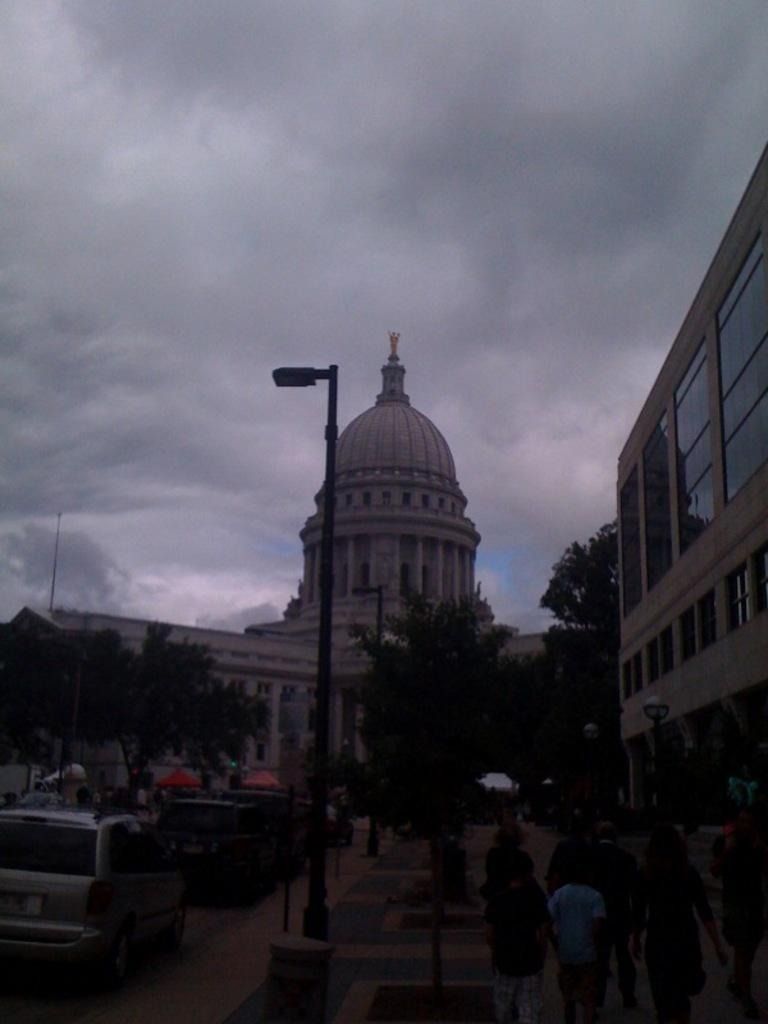What types of objects can be seen in the image? There are vehicles, light poles, trees, and buildings in the image. Can you describe the color scheme of the buildings? The buildings are in cream and white color. What is the color of the sky in the image? The sky is in white and gray color in the image. Where is the nest located in the image? There is no nest present in the image. What type of cabbage can be seen growing near the light poles? There is no cabbage present in the image. 